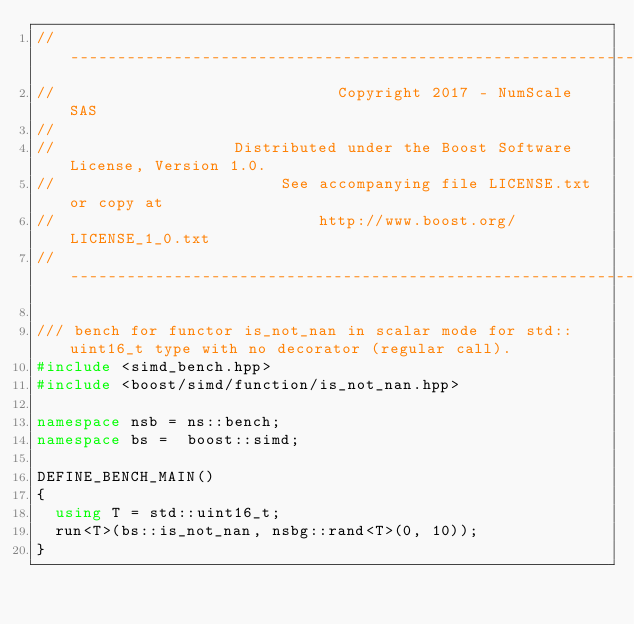<code> <loc_0><loc_0><loc_500><loc_500><_C++_>// -------------------------------------------------------------------------------------------------
//                              Copyright 2017 - NumScale SAS
//
//                   Distributed under the Boost Software License, Version 1.0.
//                        See accompanying file LICENSE.txt or copy at
//                            http://www.boost.org/LICENSE_1_0.txt
// -------------------------------------------------------------------------------------------------

/// bench for functor is_not_nan in scalar mode for std::uint16_t type with no decorator (regular call).
#include <simd_bench.hpp>
#include <boost/simd/function/is_not_nan.hpp>

namespace nsb = ns::bench;
namespace bs =  boost::simd;

DEFINE_BENCH_MAIN()
{
  using T = std::uint16_t;
  run<T>(bs::is_not_nan, nsbg::rand<T>(0, 10));
}

</code> 